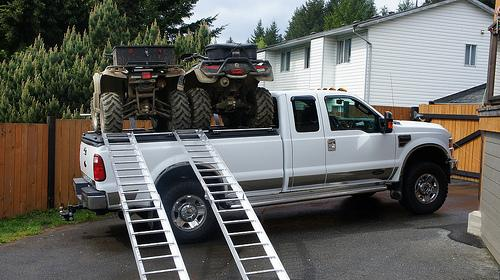Can you please tell what objects are there in the sky portion of the image? There are clouds in the sky, and it appears to be daytime. Enumerate the main elements present in the image. White truck, ATVs, aluminum ramps, trailer hitch, tail light, tires, pine trees, white house, fence, and sky. Could you provide a brief description of the setting where this image has been captured? The image is set outside, during daytime, with a white truck loaded with ATVs, parked next to a fence with a white house in the background. What emotions does this image evoke to the viewer? The image may evoke a feeling of readiness for adventure, as it appears that the truck is about to transport the ATVs, possibly for recreational purposes. What is the most prominent objects in the foreground and what is in the background? A white pickup truck with ATVs and ramps in the foreground, and a white house and fence in the background. Count the total number of ramps and ATVs in the image and describe their colors. There are two aluminum ramps and two ATVs in the image. Estimate the image quality in terms of sharpness and clarity. The image is quite clear and sharp, with well-defined objects throughout the scene. What types of trees can be seen in the image, and where are they located? The tops of pine trees can be seen on the left side of the image. Identify the main vehicle in the image and its most notable feature. A white pickup truck with two ATVs on the back and aluminum ramps to facilitate loading. Please provide an analysis of the object interaction occurring in the image. The two aluminum ramps have been used to load the ATVs onto the back of the truck, and are still in place, showing the vehicle's readiness for transportation. Can you see a red sports car in the parking lot? No, it's not mentioned in the image. Is there a person loading the ATV onto the truck? There is no mention of people in the captured objects in the image, only vehicles, a fence, a house, and trees. Do you notice any street signs around the scene? There are no mentions of street signs in the scene, the scene includes a white truck, ATVs, house, trees, and fence being mentioned, but no street signs. Is it raining in the image? The image is described as having a blue sky with clouds and being a scene during the day, indicating clear weather, so it's not implied that it is raining. Is the fence made of metal and painted blue? The fence in the image is described as a brown wooden fence and a tan fence, not a metal and blue one. 